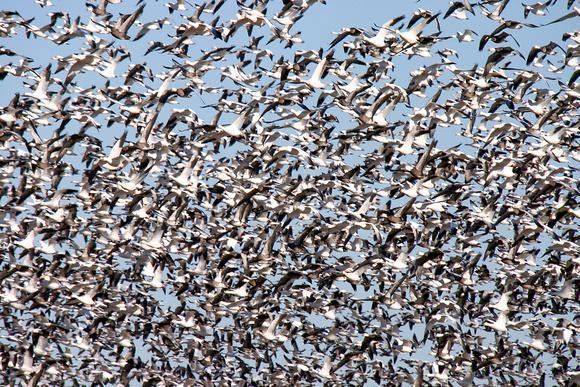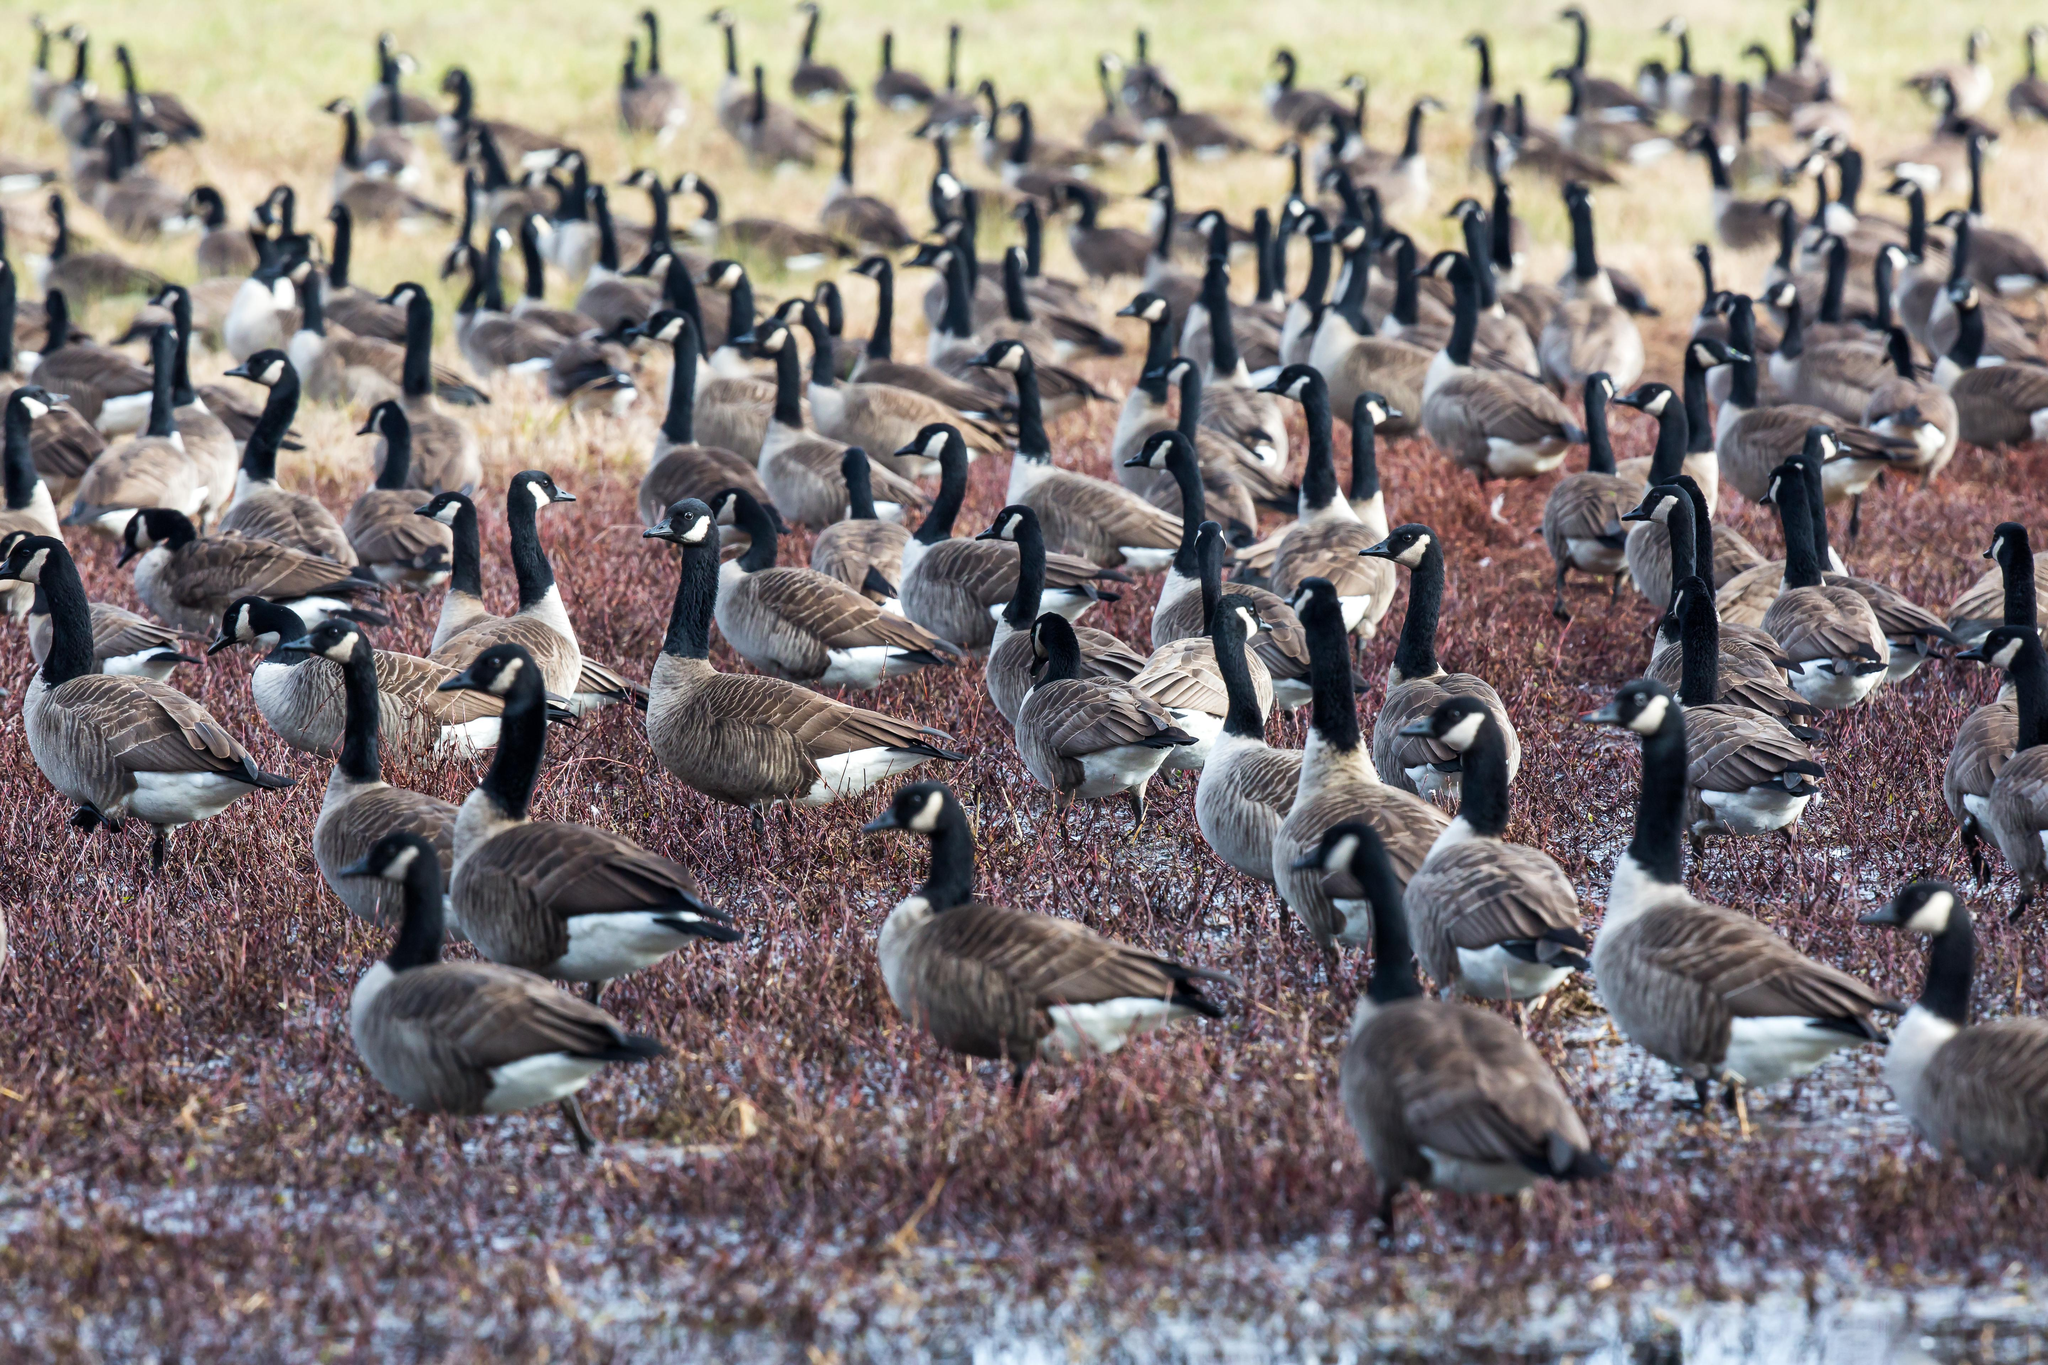The first image is the image on the left, the second image is the image on the right. Given the left and right images, does the statement "An image contains a person facing a large group of ducks," hold true? Answer yes or no. No. The first image is the image on the left, the second image is the image on the right. Evaluate the accuracy of this statement regarding the images: "A man holding a stick is along the side of a road filled with walking geese, and another man is in the foreground behind the geese.". Is it true? Answer yes or no. No. 